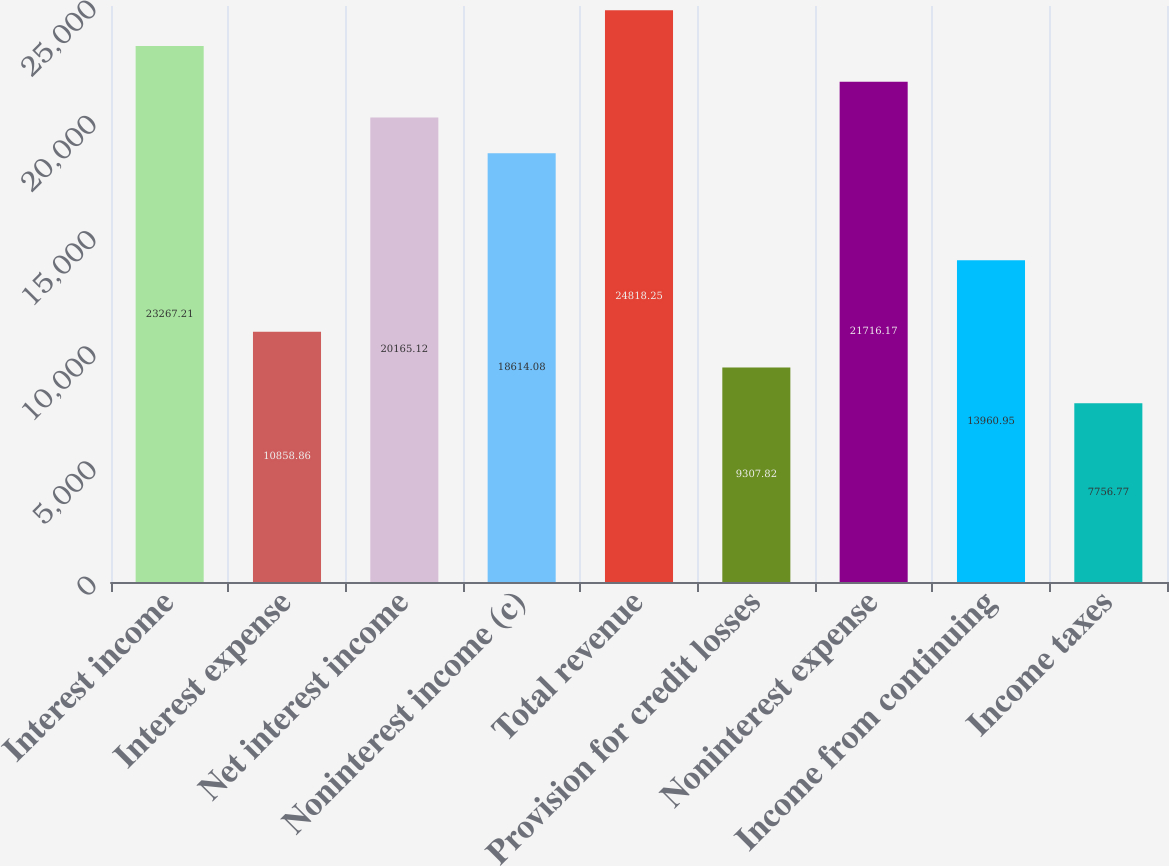<chart> <loc_0><loc_0><loc_500><loc_500><bar_chart><fcel>Interest income<fcel>Interest expense<fcel>Net interest income<fcel>Noninterest income (c)<fcel>Total revenue<fcel>Provision for credit losses<fcel>Noninterest expense<fcel>Income from continuing<fcel>Income taxes<nl><fcel>23267.2<fcel>10858.9<fcel>20165.1<fcel>18614.1<fcel>24818.2<fcel>9307.82<fcel>21716.2<fcel>13961<fcel>7756.77<nl></chart> 